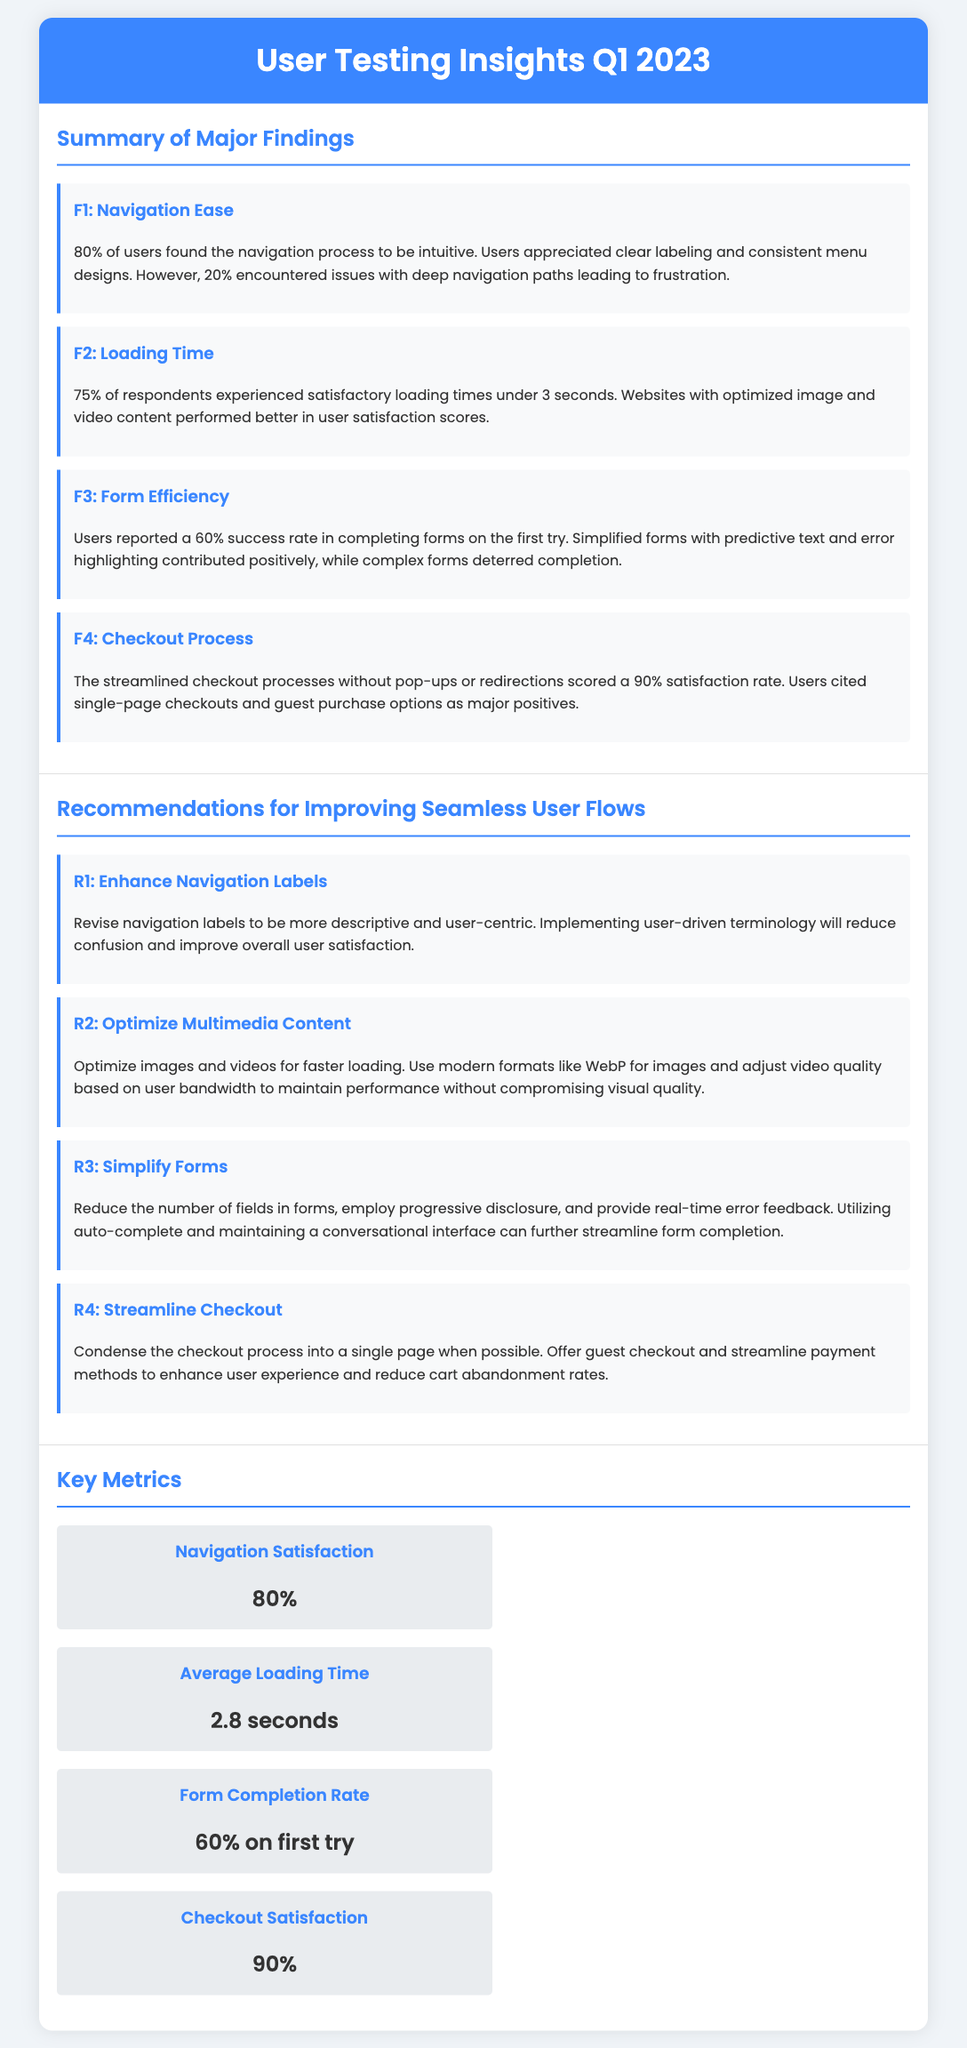What percentage of users found navigation intuitive? The finding states that 80% of users found the navigation process to be intuitive.
Answer: 80% What was the average loading time reported? The document indicates the average loading time was 2.8 seconds.
Answer: 2.8 seconds What is the success rate for form completion on the first try? The success rate for form completion mentioned in the document is 60%.
Answer: 60% What percentage satisfaction rate did the streamlined checkout process receive? The streamlined checkout processes received a satisfaction rate of 90%.
Answer: 90% What is a recommended action for enhancing navigation labels? The document recommends revising navigation labels to be more descriptive and user-centric.
Answer: Revise navigation labels What multimedia optimization is suggested in the recommendations? The recommendations suggest optimizing images and videos for faster loading.
Answer: Optimize images and videos What was the reported success factor in the checkout process? Users cited single-page checkouts and guest purchase options as major positives.
Answer: Single-page checkouts How many major findings are summarized in the document? The document summarizes four major findings related to user testing insights.
Answer: Four What method is recommended for simplifying forms? The recommendation states to reduce the number of fields in forms and provide real-time error feedback.
Answer: Reduce the number of fields What is the main goal of the document? The main goal is to present user testing insights and recommendations for improving seamless user flows.
Answer: Present user testing insights 